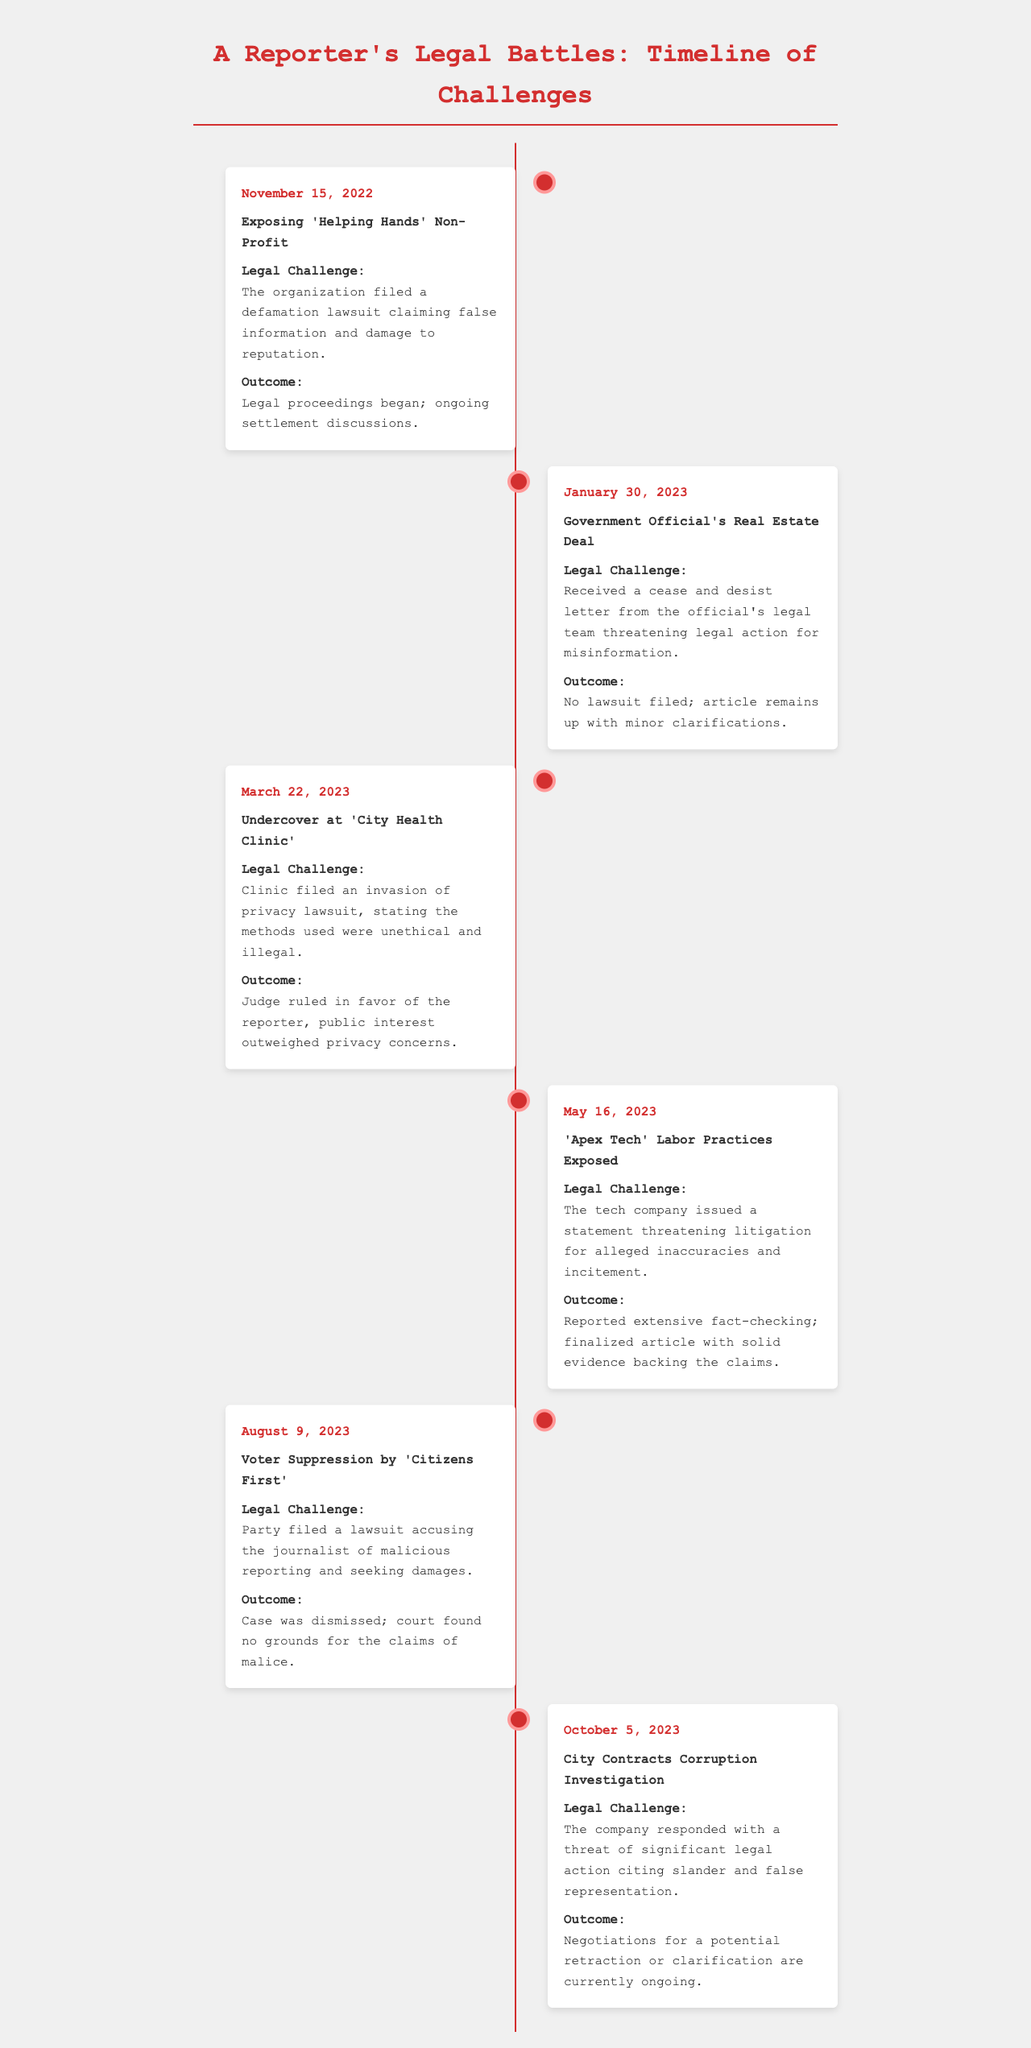what was the date of the first legal challenge? The first legal challenge occurred on November 15, 2022.
Answer: November 15, 2022 how many legal challenges are listed in the document? The document lists a total of six legal challenges faced by the reporter.
Answer: 6 what was the outcome of the legal challenge regarding 'City Health Clinic'? The judge ruled in favor of the reporter, considering the public interest outweighed privacy concerns.
Answer: Ruling in favor of the reporter which organization was accused of voter suppression? The organization accused of voter suppression is 'Citizens First'.
Answer: Citizens First what was the response from 'Apex Tech' regarding labor practices? 'Apex Tech' issued a statement threatening litigation for alleged inaccuracies and incitement.
Answer: Threatening litigation what were the ongoing discussions regarding the City Contracts Corruption Investigation? Negotiations for a potential retraction or clarification are currently ongoing.
Answer: Ongoing negotiations which lawsuit claimed false information related to a government official? The lawsuit related to the government official's real estate deal claimed false information.
Answer: Government Official's Real Estate Deal what is the common theme among the legal challenges faced? The common theme involves defamation, misinformation, or ethical reporting practices.
Answer: Defamation and misinformation 